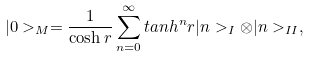Convert formula to latex. <formula><loc_0><loc_0><loc_500><loc_500>| 0 > _ { M } = \frac { 1 } { \cosh r } \sum ^ { \infty } _ { n = 0 } t a n h ^ { n } r | n > _ { I } \otimes | n > _ { I I } ,</formula> 